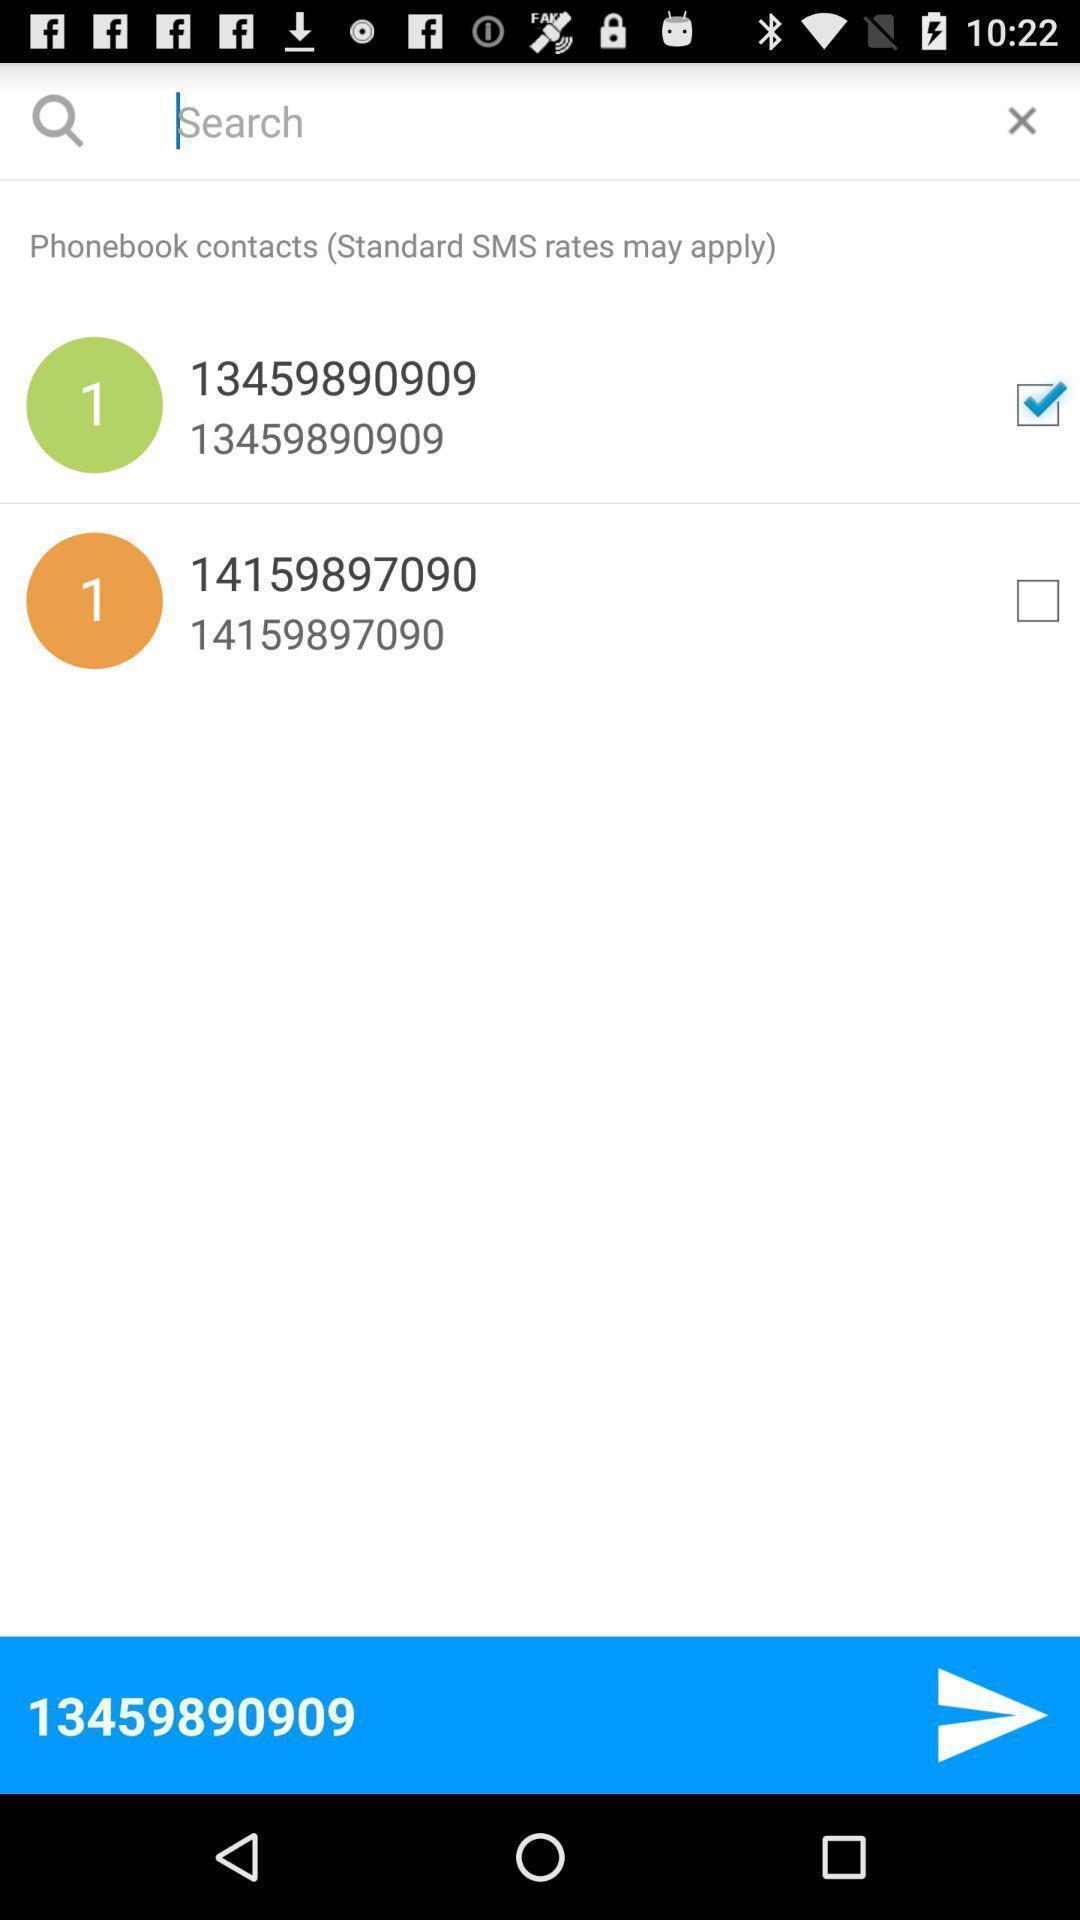Explain what's happening in this screen capture. Search page for finding contacts on messaging app. 